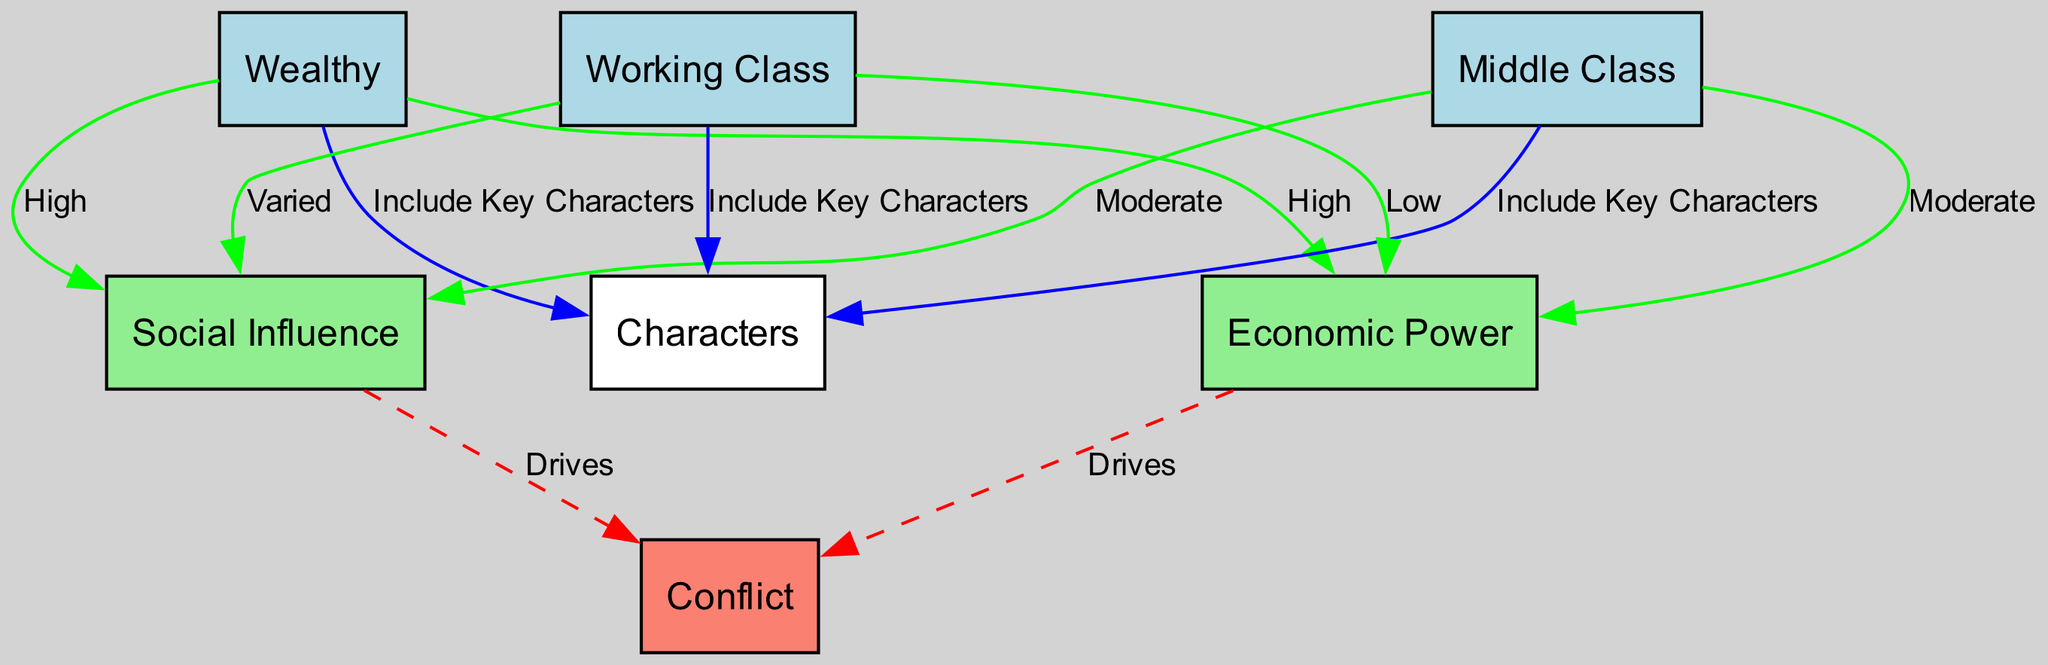What are the three socioeconomic classes represented? The diagram specifically identifies three classes: Wealthy, Middle Class, and Working Class. Each class is represented as a node connected to the "Characters" node, indicating key characters in the show.
Answer: Wealthy, Middle Class, Working Class Which class has "High" Economic Power? According to the connections in the diagram, the Wealthy class has a directed edge to the Economic Power node labeled "High," indicating they possess high economic power.
Answer: Wealthy How many nodes are in the diagram? The diagram contains six nodes: Wealthy, Middle Class, Working Class, Characters, Economic Power, Social Influence, and Conflict. Counting all these nodes gives us a total of six.
Answer: 6 What type of influence does the Working Class have? The diagram indicates that the Working Class has "Varied" social influence, which is reflected in the edge connecting this class to the Social Influence node.
Answer: Varied What does Economic Power drive according to the diagram? The diagram illustrates a connection from the Economic Power node to the Conflict node, labeled "Drives." This signifies that Economic Power contributes to or drives conflict within the narrative.
Answer: Conflict Which socioeconomic class is connected to the "Characters"? The edges connecting the Wealthy, Middle Class, and Working Class all lead to the Characters node, which demonstrates that all three classes include key characters in the show.
Answer: Wealthy, Middle Class, Working Class What label describes the influence of the Middle Class? The edge from Middle Class to Social Influence is labeled "Moderate," meaning that the Middle Class holds a moderate level of social influence in the context of the narrative.
Answer: Moderate How many edges are related to conflict? The diagram shows two edges leading to the Conflict node — one from Economic Power and another from Social Influence. Therefore, there are a total of two edges related to conflict.
Answer: 2 What category does "Social Influence" fall under in the diagram? The Social Influence is categorized in the diagram as an attribute related to the classes, identified by the connections from different socioeconomic classes, denoting their influence within the story.
Answer: Social Influence 